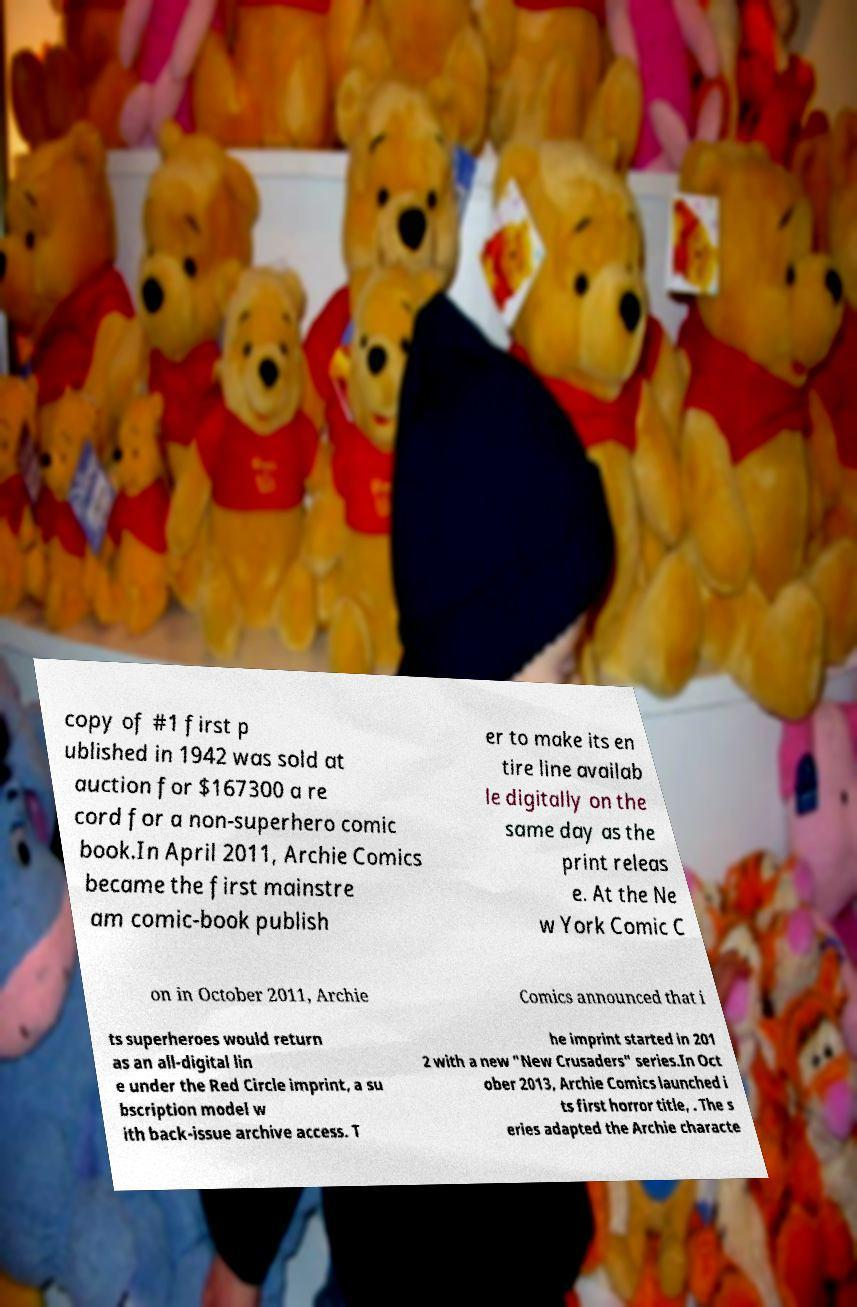Can you accurately transcribe the text from the provided image for me? copy of #1 first p ublished in 1942 was sold at auction for $167300 a re cord for a non-superhero comic book.In April 2011, Archie Comics became the first mainstre am comic-book publish er to make its en tire line availab le digitally on the same day as the print releas e. At the Ne w York Comic C on in October 2011, Archie Comics announced that i ts superheroes would return as an all-digital lin e under the Red Circle imprint, a su bscription model w ith back-issue archive access. T he imprint started in 201 2 with a new "New Crusaders" series.In Oct ober 2013, Archie Comics launched i ts first horror title, . The s eries adapted the Archie characte 